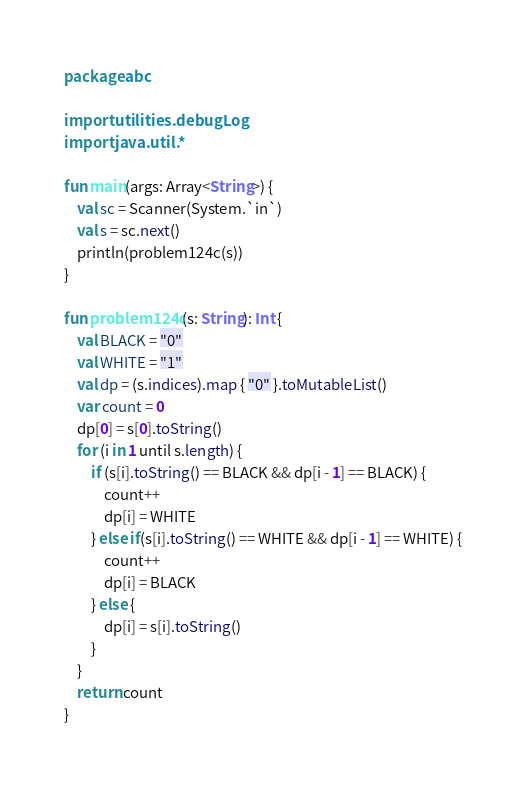Convert code to text. <code><loc_0><loc_0><loc_500><loc_500><_Kotlin_>package abc

import utilities.debugLog
import java.util.*

fun main(args: Array<String>) {
    val sc = Scanner(System.`in`)
    val s = sc.next()
    println(problem124c(s))
}

fun problem124c(s: String): Int {
    val BLACK = "0"
    val WHITE = "1"
    val dp = (s.indices).map { "0" }.toMutableList()
    var count = 0
    dp[0] = s[0].toString()
    for (i in 1 until s.length) {
        if (s[i].toString() == BLACK && dp[i - 1] == BLACK) {
            count++
            dp[i] = WHITE
        } else if(s[i].toString() == WHITE && dp[i - 1] == WHITE) {
            count++
            dp[i] = BLACK
        } else {
            dp[i] = s[i].toString()
        }
    }
    return count
}</code> 